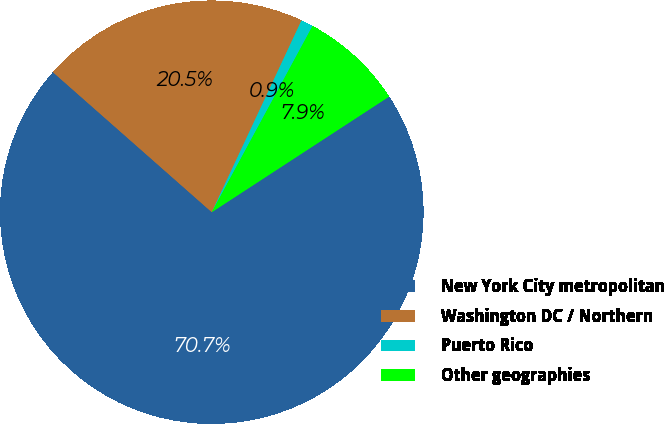Convert chart to OTSL. <chart><loc_0><loc_0><loc_500><loc_500><pie_chart><fcel>New York City metropolitan<fcel>Washington DC / Northern<fcel>Puerto Rico<fcel>Other geographies<nl><fcel>70.7%<fcel>20.47%<fcel>0.93%<fcel>7.91%<nl></chart> 